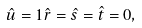<formula> <loc_0><loc_0><loc_500><loc_500>\hat { u } = 1 \hat { r } = \hat { s } = \hat { t } = 0 ,</formula> 